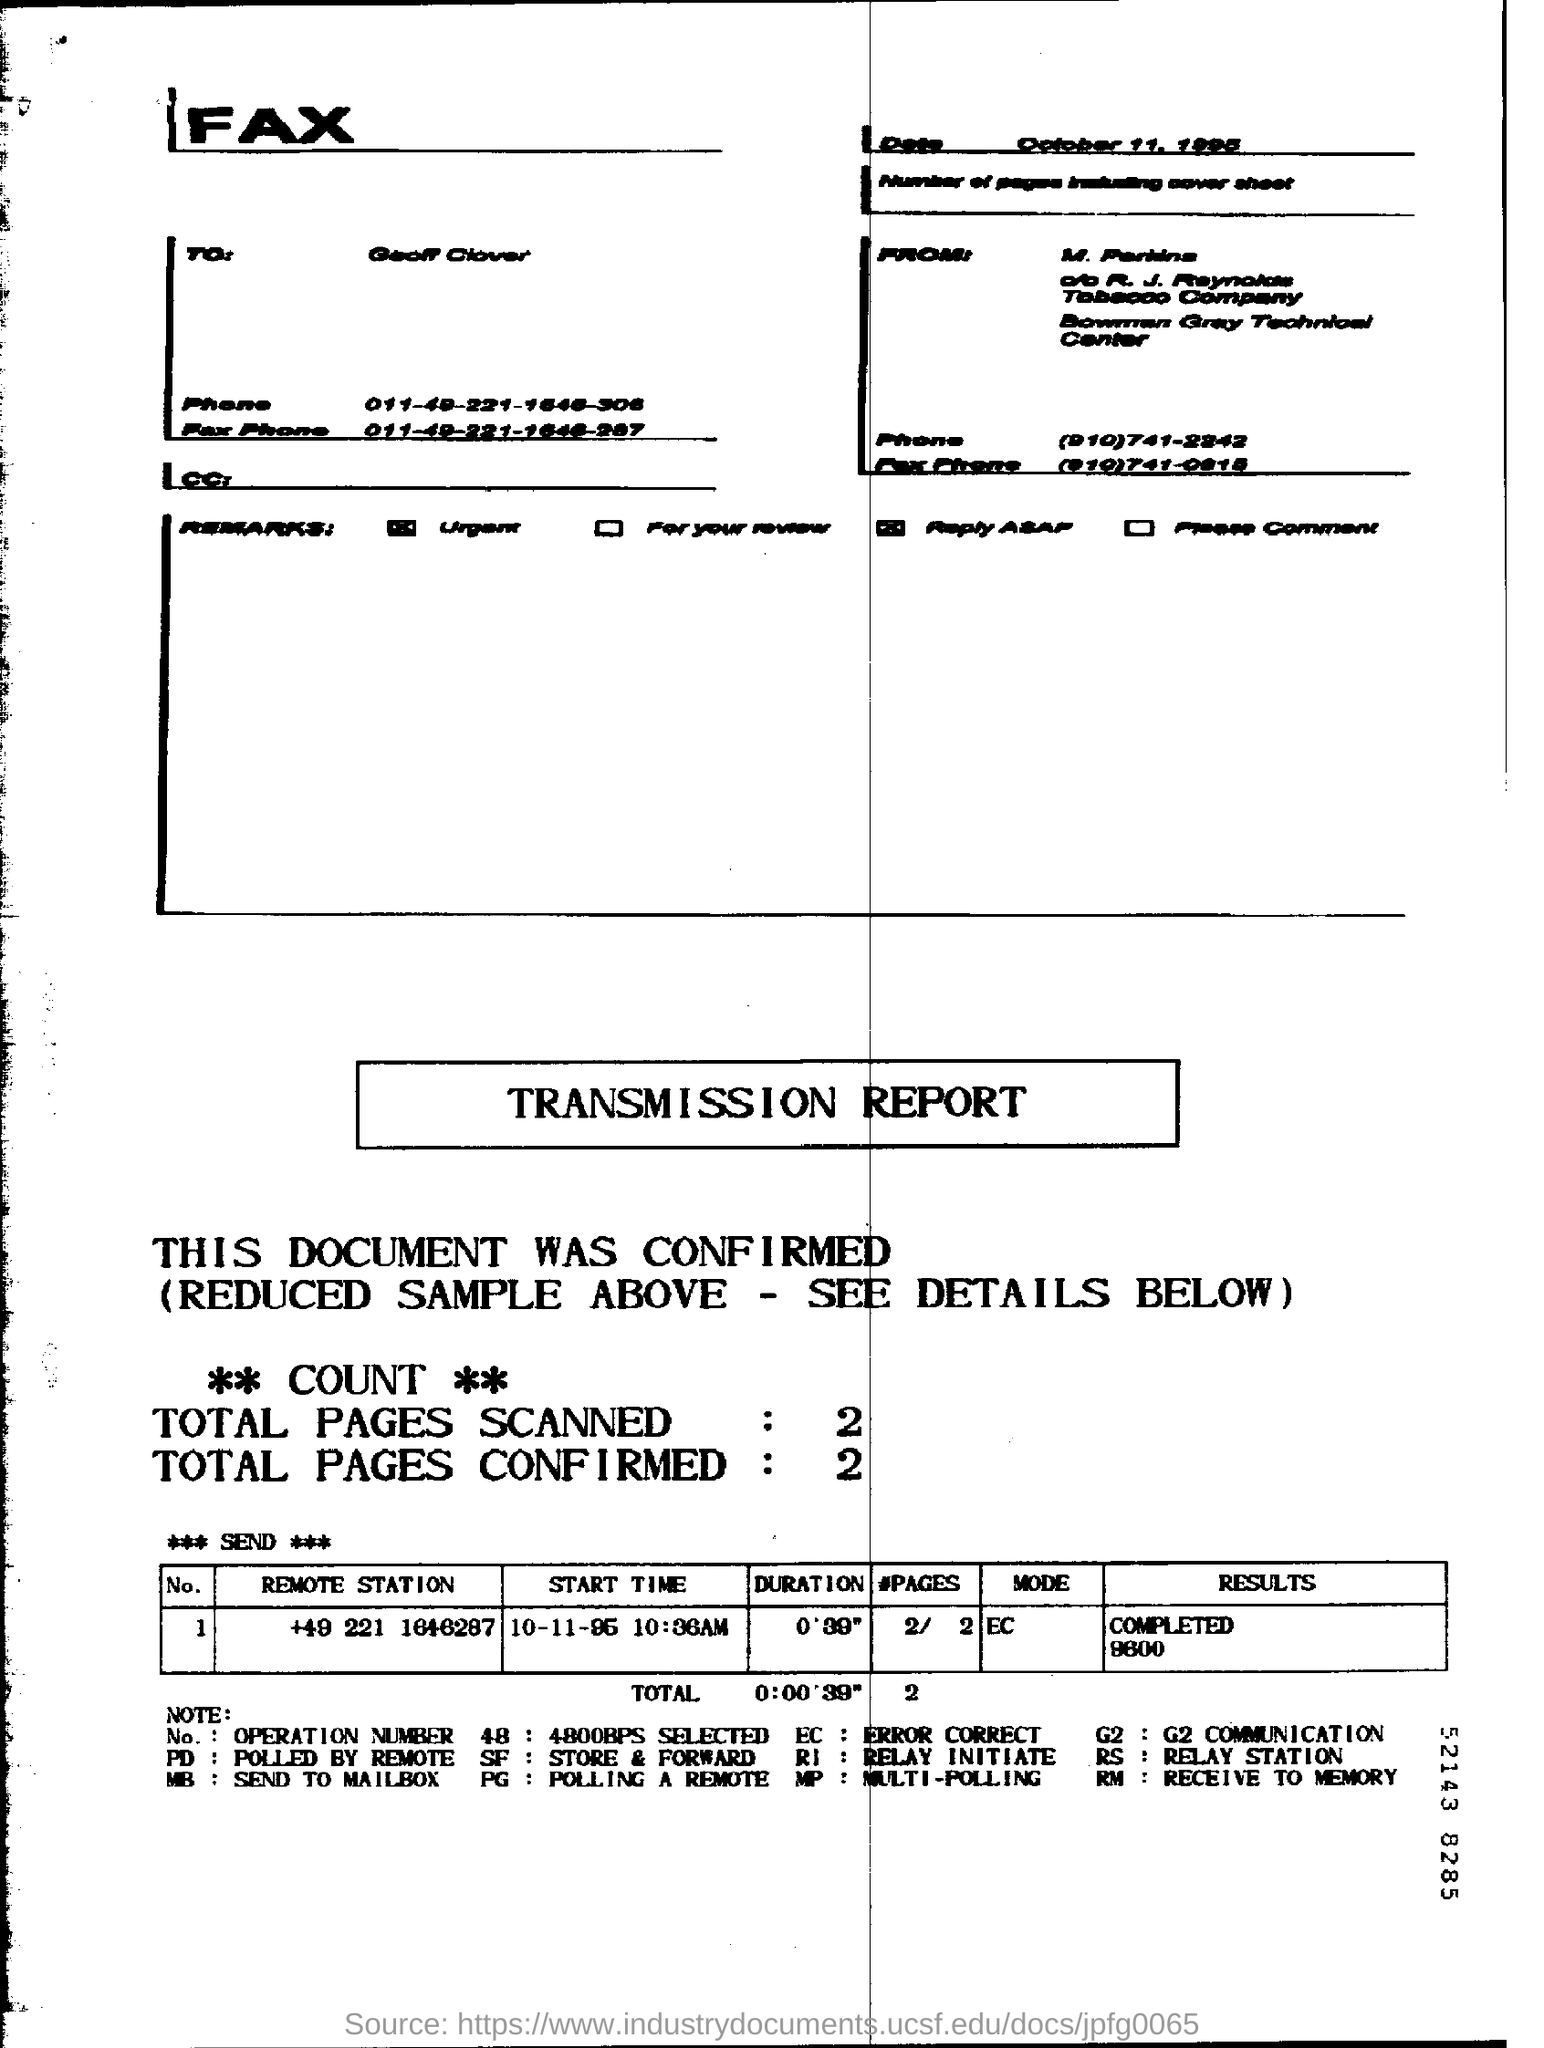Identify some key points in this picture. The total number of pages scanned is 2.. The date is October 11, 1995. The mode for the remote station +49 221 1646287 is EC. The total number of confirmed pages is currently 2. 